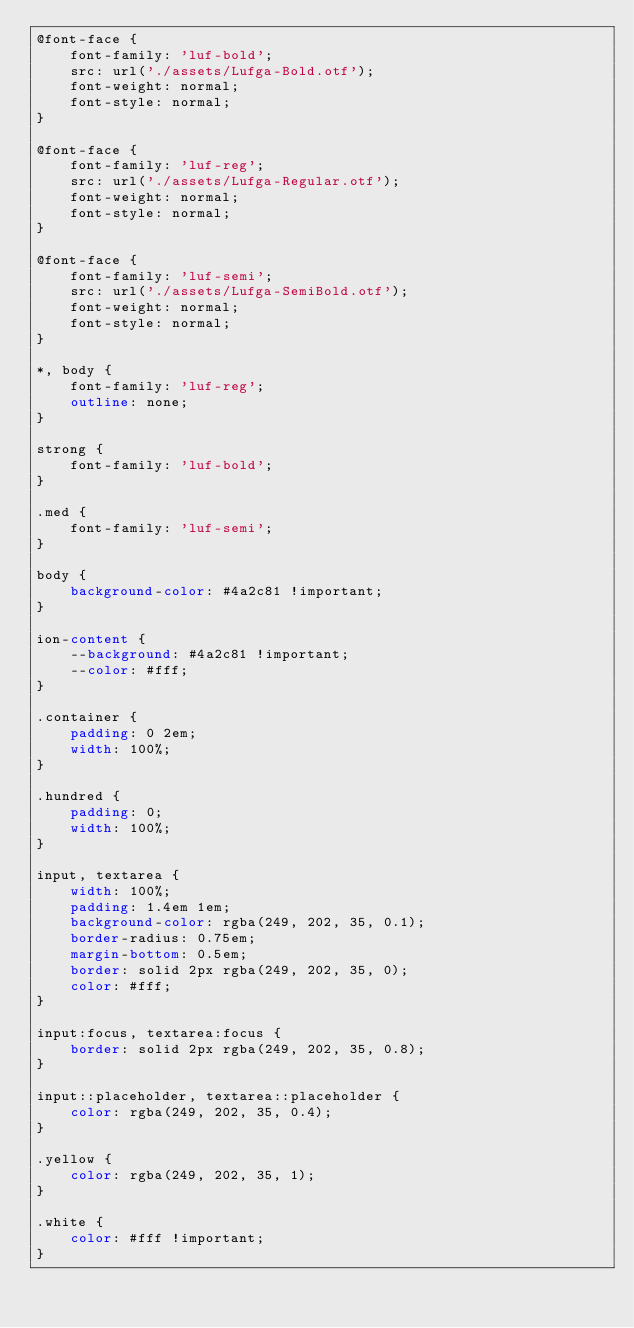Convert code to text. <code><loc_0><loc_0><loc_500><loc_500><_CSS_>@font-face {
	font-family: 'luf-bold';
	src: url('./assets/Lufga-Bold.otf');
	font-weight: normal;
	font-style: normal;
}

@font-face {
	font-family: 'luf-reg';
	src: url('./assets/Lufga-Regular.otf');
	font-weight: normal;
	font-style: normal;
}

@font-face {
	font-family: 'luf-semi';
	src: url('./assets/Lufga-SemiBold.otf');
	font-weight: normal;
	font-style: normal;
}

*, body {
	font-family: 'luf-reg';
	outline: none;
}

strong {
	font-family: 'luf-bold';
}

.med {
	font-family: 'luf-semi';
}

body {
	background-color: #4a2c81 !important;
}

ion-content {
	--background: #4a2c81 !important;
	--color: #fff;
}

.container {
	padding: 0 2em;
	width: 100%;
}

.hundred {
	padding: 0;
	width: 100%;
}

input, textarea {
	width: 100%;
	padding: 1.4em 1em;
	background-color: rgba(249, 202, 35, 0.1);
	border-radius: 0.75em;
	margin-bottom: 0.5em;
	border: solid 2px rgba(249, 202, 35, 0);
	color: #fff;
}

input:focus, textarea:focus {
	border: solid 2px rgba(249, 202, 35, 0.8);
}

input::placeholder, textarea::placeholder {
	color: rgba(249, 202, 35, 0.4);
}

.yellow {
	color: rgba(249, 202, 35, 1);
}

.white {
	color: #fff !important;
}</code> 